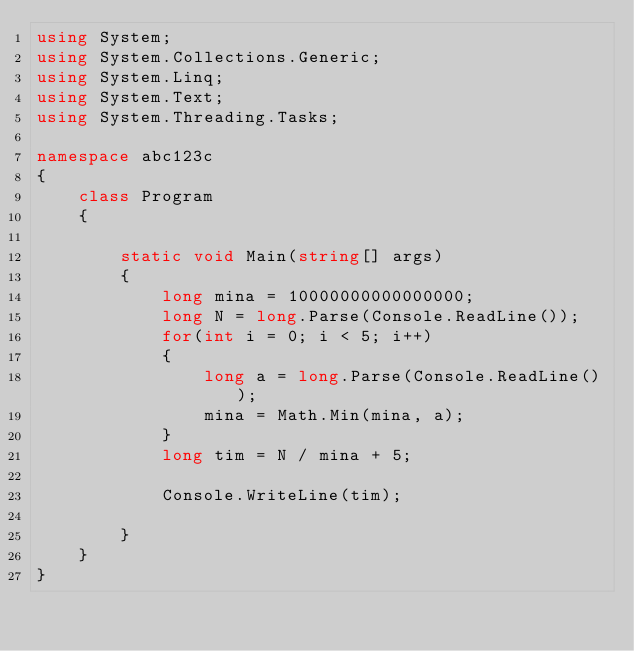Convert code to text. <code><loc_0><loc_0><loc_500><loc_500><_C#_>using System;
using System.Collections.Generic;
using System.Linq;
using System.Text;
using System.Threading.Tasks;

namespace abc123c
{
    class Program
    {
        
        static void Main(string[] args)
        {
            long mina = 10000000000000000;
            long N = long.Parse(Console.ReadLine());
            for(int i = 0; i < 5; i++)
            {
                long a = long.Parse(Console.ReadLine());
                mina = Math.Min(mina, a);
            }
            long tim = N / mina + 5;

            Console.WriteLine(tim);

        }
    }
}
</code> 